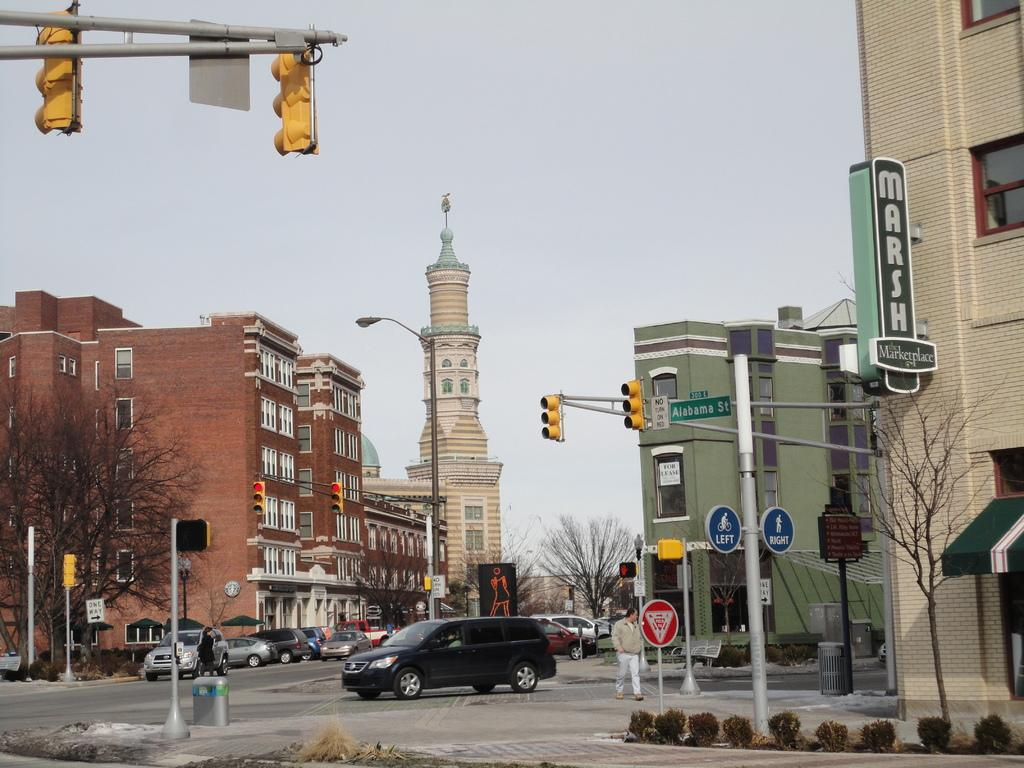<image>
Give a short and clear explanation of the subsequent image. A sign on the right advertises the Marsh Marketplace. 